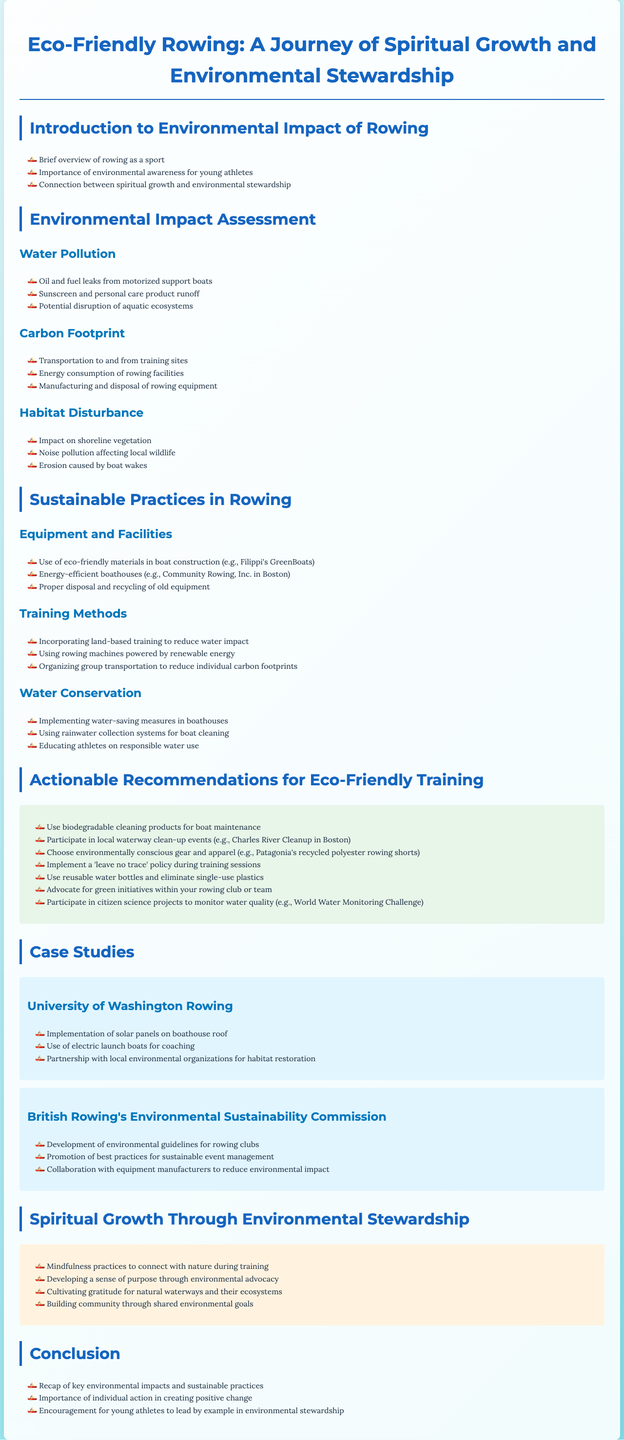What is the title of the report? The title is found at the beginning of the document, summarizing its focus on eco-friendly practices in rowing.
Answer: Eco-Friendly Rowing: A Journey of Spiritual Growth and Environmental Stewardship What is one key aspect of environmental awareness for young athletes mentioned in the introduction? The introduction highlights the importance of young athletes being aware of their environmental impact and how it connects to their personal growth.
Answer: Environmental awareness What are two sources of water pollution listed in the assessment? The document specifies multiple sources of water pollution; two examples are oil leaks and sunscreen runoff.
Answer: Oil leaks, sunscreen runoff How many actionable recommendations for eco-friendly training are provided? The recommendations section details seven distinct actions that athletes can take to promote eco-friendly practices.
Answer: Seven What is one eco-friendly material mentioned for boat construction? The report provides examples of sustainable materials; one specified is used in Filippi's GreenBoats.
Answer: Eco-friendly materials What is the focus of the case study on the University of Washington Rowing? This case study includes innovative practices that enhance environmental sustainability within their rowing program.
Answer: Use of solar panels, electric launch boats What practice does the document recommend for promoting mindfulness during training? The spiritual growth section emphasizes connecting with nature, which is well-integrated into the training experience.
Answer: Mindfulness practices What is one recommendation related to water conservation? The recommendations section suggests various sustainable practices, and one focuses specifically on water conservation measures.
Answer: Implementing water-saving measures What are athletes encouraged to participate in to monitor water quality? The document highlights specific community engagement projects that athletes can join for environmental monitoring.
Answer: World Water Monitoring Challenge 